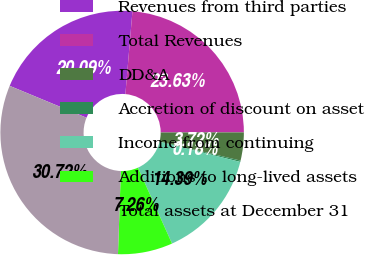<chart> <loc_0><loc_0><loc_500><loc_500><pie_chart><fcel>Revenues from third parties<fcel>Total Revenues<fcel>DD&A<fcel>Accretion of discount on asset<fcel>Income from continuing<fcel>Additions to long-lived assets<fcel>Total assets at December 31<nl><fcel>20.09%<fcel>23.63%<fcel>3.72%<fcel>0.18%<fcel>14.39%<fcel>7.26%<fcel>30.71%<nl></chart> 